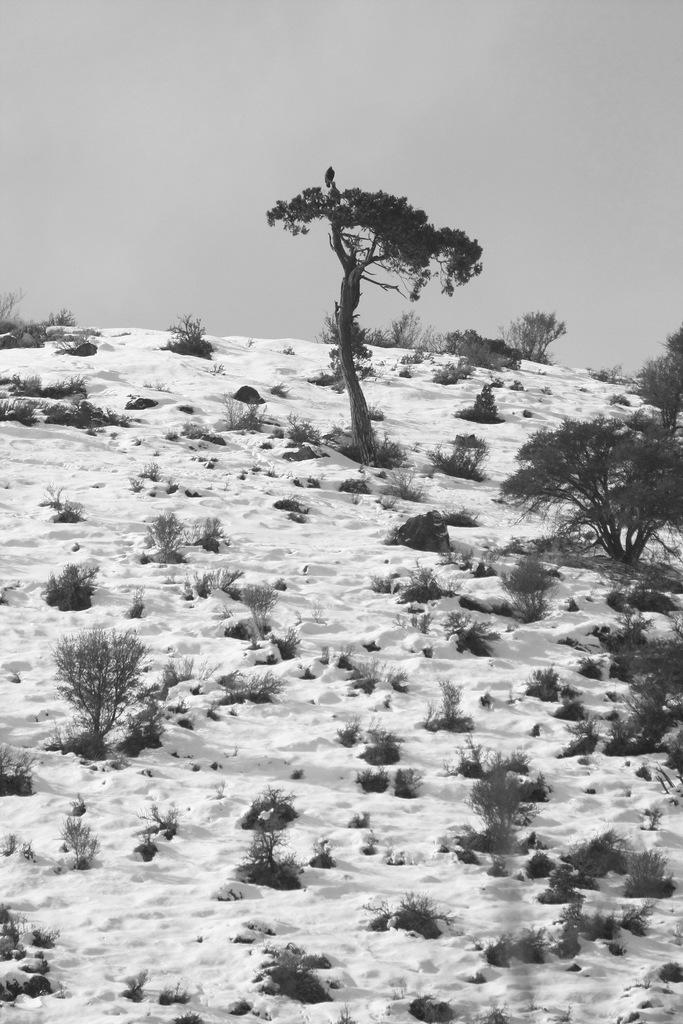What type of natural elements are present in the image? The image contains trees and plants. What is covering the ground in the image? There is snow at the bottom of the image. What part of the natural environment is visible in the image? The sky is visible at the top of the image. Can you describe any living creatures in the image? Yes, there is a bird is present on one of the trees. How many pigs are visible in the image? There are no pigs present in the image; it features trees, plants, snow, sky, and a bird. 